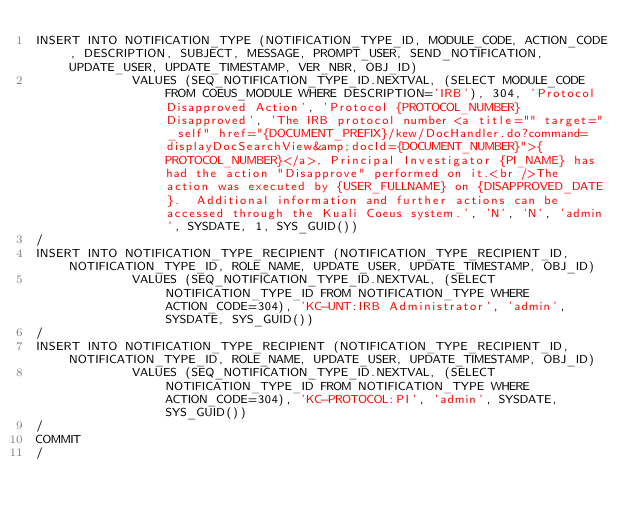Convert code to text. <code><loc_0><loc_0><loc_500><loc_500><_SQL_>INSERT INTO NOTIFICATION_TYPE (NOTIFICATION_TYPE_ID, MODULE_CODE, ACTION_CODE, DESCRIPTION, SUBJECT, MESSAGE, PROMPT_USER, SEND_NOTIFICATION, UPDATE_USER, UPDATE_TIMESTAMP, VER_NBR, OBJ_ID)
             VALUES (SEQ_NOTIFICATION_TYPE_ID.NEXTVAL, (SELECT MODULE_CODE FROM COEUS_MODULE WHERE DESCRIPTION='IRB'), 304, 'Protocol Disapproved Action', 'Protocol {PROTOCOL_NUMBER} Disapproved', 'The IRB protocol number <a title="" target="_self" href="{DOCUMENT_PREFIX}/kew/DocHandler.do?command=displayDocSearchView&amp;docId={DOCUMENT_NUMBER}">{PROTOCOL_NUMBER}</a>, Principal Investigator {PI_NAME} has had the action "Disapprove" performed on it.<br />The action was executed by {USER_FULLNAME} on {DISAPPROVED_DATE}.  Additional information and further actions can be accessed through the Kuali Coeus system.', 'N', 'N', 'admin', SYSDATE, 1, SYS_GUID())
/
INSERT INTO NOTIFICATION_TYPE_RECIPIENT (NOTIFICATION_TYPE_RECIPIENT_ID, NOTIFICATION_TYPE_ID, ROLE_NAME, UPDATE_USER, UPDATE_TIMESTAMP, OBJ_ID)
             VALUES (SEQ_NOTIFICATION_TYPE_ID.NEXTVAL, (SELECT NOTIFICATION_TYPE_ID FROM NOTIFICATION_TYPE WHERE ACTION_CODE=304), 'KC-UNT:IRB Administrator', 'admin', SYSDATE, SYS_GUID())
/
INSERT INTO NOTIFICATION_TYPE_RECIPIENT (NOTIFICATION_TYPE_RECIPIENT_ID, NOTIFICATION_TYPE_ID, ROLE_NAME, UPDATE_USER, UPDATE_TIMESTAMP, OBJ_ID)
             VALUES (SEQ_NOTIFICATION_TYPE_ID.NEXTVAL, (SELECT NOTIFICATION_TYPE_ID FROM NOTIFICATION_TYPE WHERE ACTION_CODE=304), 'KC-PROTOCOL:PI', 'admin', SYSDATE, SYS_GUID())
/
COMMIT
/
</code> 